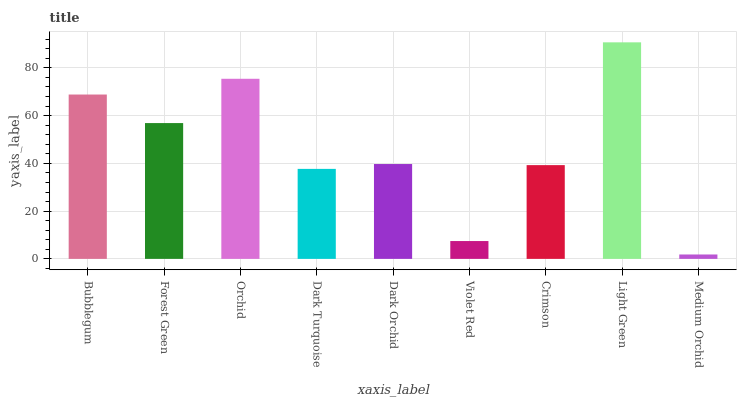Is Medium Orchid the minimum?
Answer yes or no. Yes. Is Light Green the maximum?
Answer yes or no. Yes. Is Forest Green the minimum?
Answer yes or no. No. Is Forest Green the maximum?
Answer yes or no. No. Is Bubblegum greater than Forest Green?
Answer yes or no. Yes. Is Forest Green less than Bubblegum?
Answer yes or no. Yes. Is Forest Green greater than Bubblegum?
Answer yes or no. No. Is Bubblegum less than Forest Green?
Answer yes or no. No. Is Dark Orchid the high median?
Answer yes or no. Yes. Is Dark Orchid the low median?
Answer yes or no. Yes. Is Forest Green the high median?
Answer yes or no. No. Is Light Green the low median?
Answer yes or no. No. 